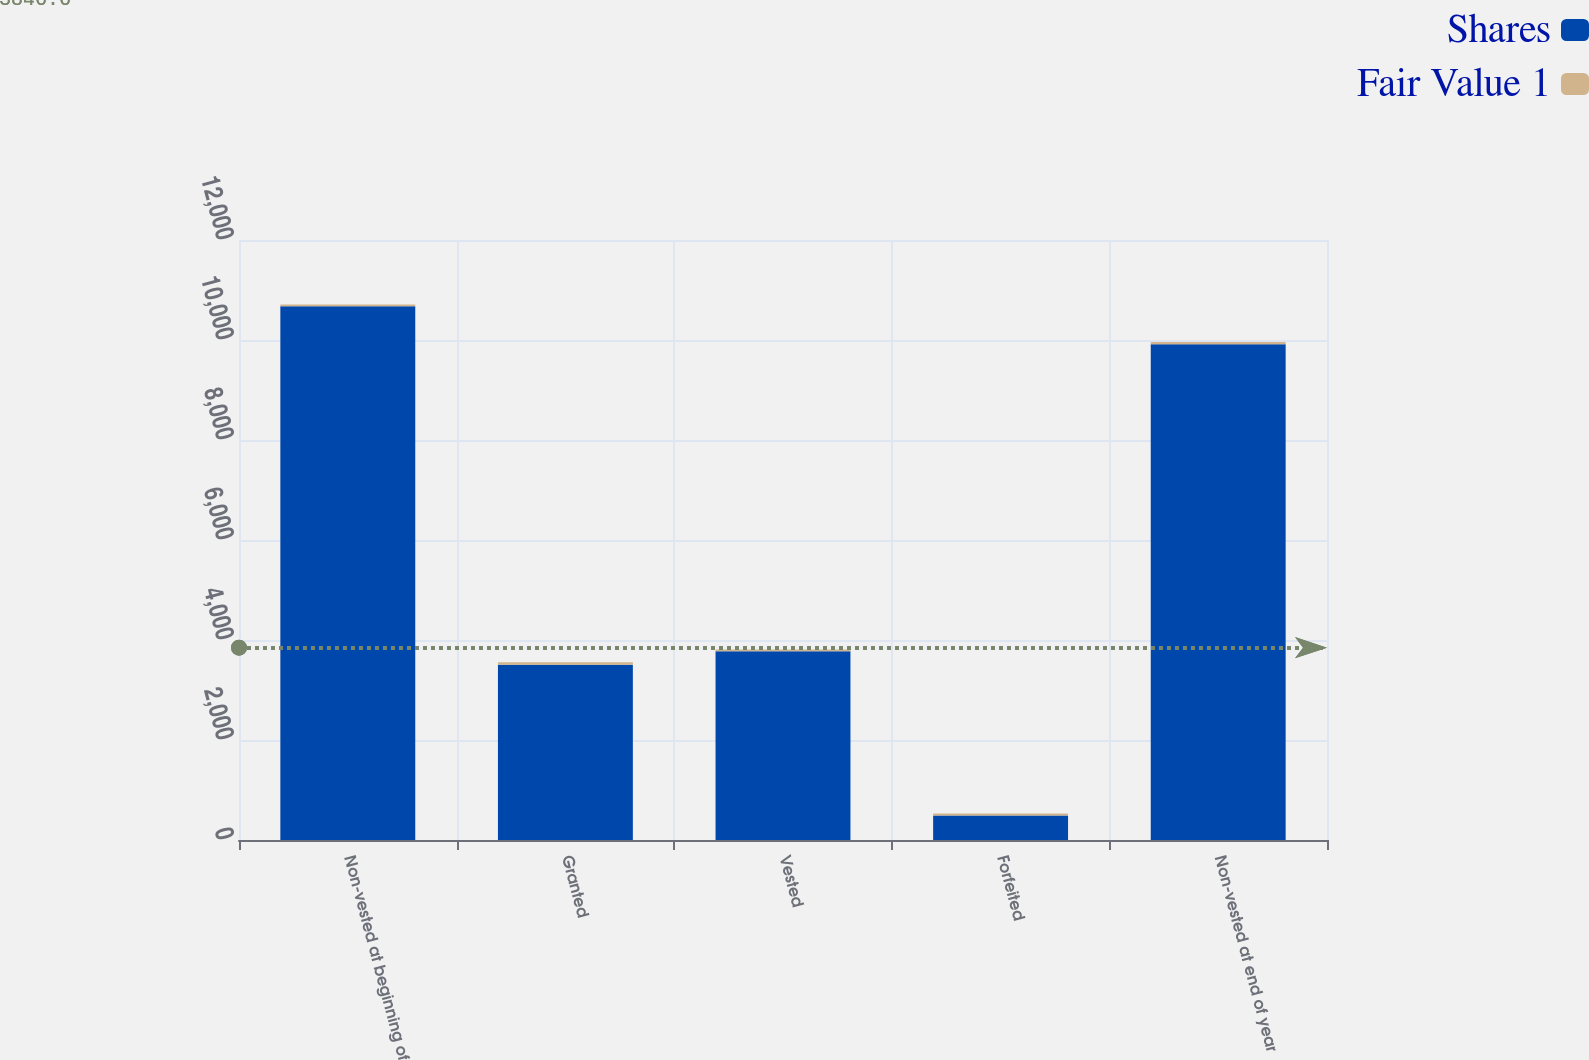<chart> <loc_0><loc_0><loc_500><loc_500><stacked_bar_chart><ecel><fcel>Non-vested at beginning of<fcel>Granted<fcel>Vested<fcel>Forfeited<fcel>Non-vested at end of year<nl><fcel>Shares<fcel>10674<fcel>3506<fcel>3773<fcel>491<fcel>9916<nl><fcel>Fair Value 1<fcel>38<fcel>51<fcel>39<fcel>39<fcel>42<nl></chart> 